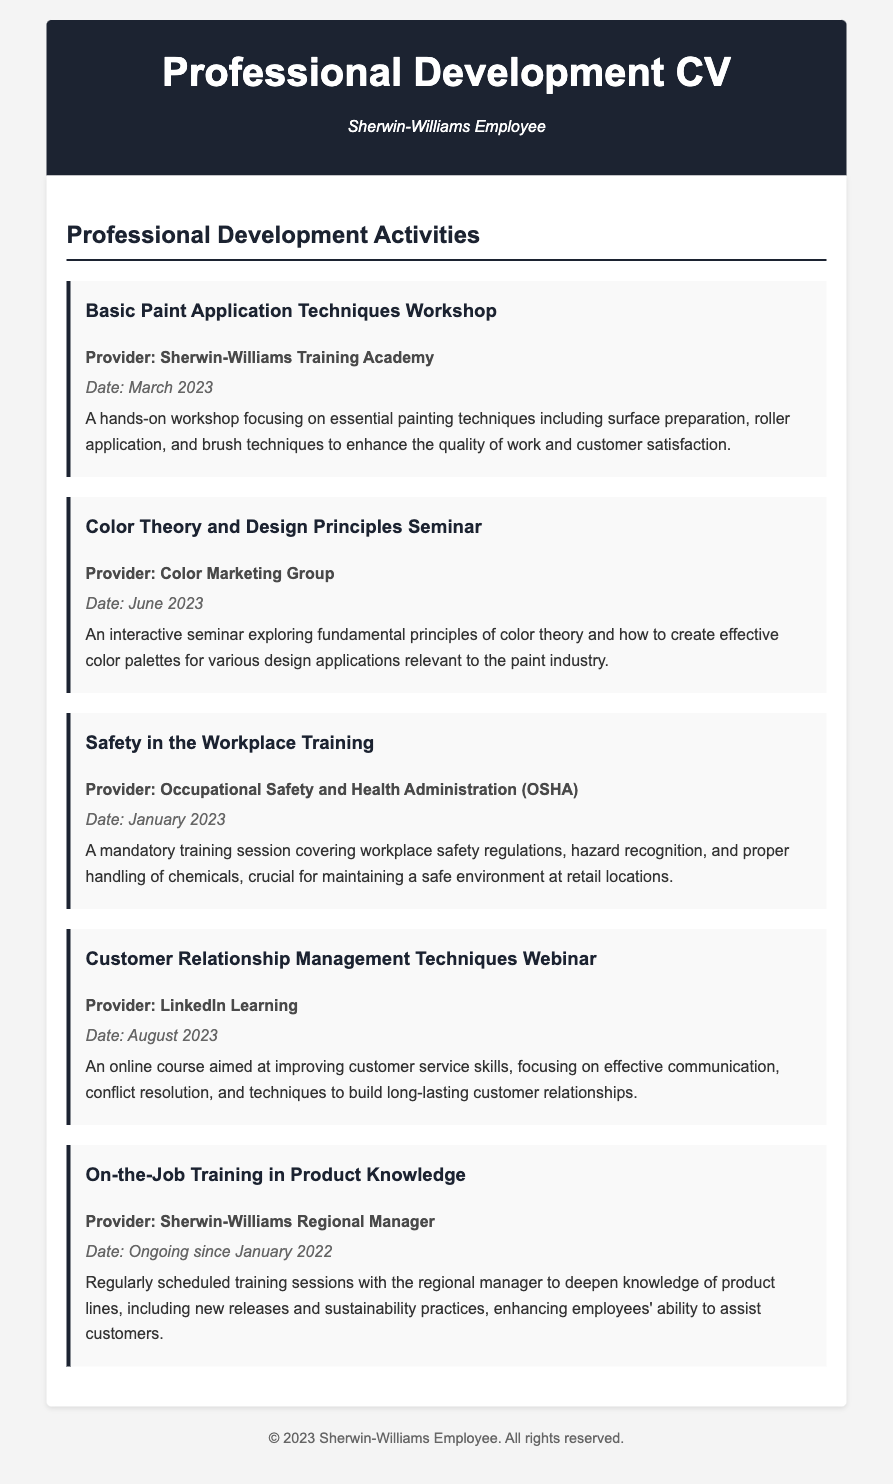what is the title of the first workshop? The title of the first workshop listed in the document is "Basic Paint Application Techniques Workshop."
Answer: Basic Paint Application Techniques Workshop who provided the Color Theory and Design Principles Seminar? The provider of the seminar is mentioned as the "Color Marketing Group."
Answer: Color Marketing Group when did the Safety in the Workplace Training occur? The date of the training is specified as January 2023 in the document.
Answer: January 2023 what is the ongoing training about? The ongoing training is about "Product Knowledge," specifically enhancing knowledge of product lines.
Answer: Product Knowledge how often are the on-the-job training sessions held? The document states that the on-the-job training sessions are "Regularly scheduled," indicating a consistent frequency.
Answer: Regularly what is the focus of the Customer Relationship Management Techniques Webinar? The focus of the webinar is "improving customer service skills," which encompasses various related techniques.
Answer: improving customer service skills how many activities are listed in the Professional Development Activities section? The document enumerates five distinct activities in this section.
Answer: Five which organization's training covers hazard recognition and chemical handling? The training related to hazard recognition and chemical handling is provided by the "Occupational Safety and Health Administration (OSHA)."
Answer: Occupational Safety and Health Administration (OSHA) what is the date of the last professional development activity listed? The last activity listed was conducted in August 2023.
Answer: August 2023 